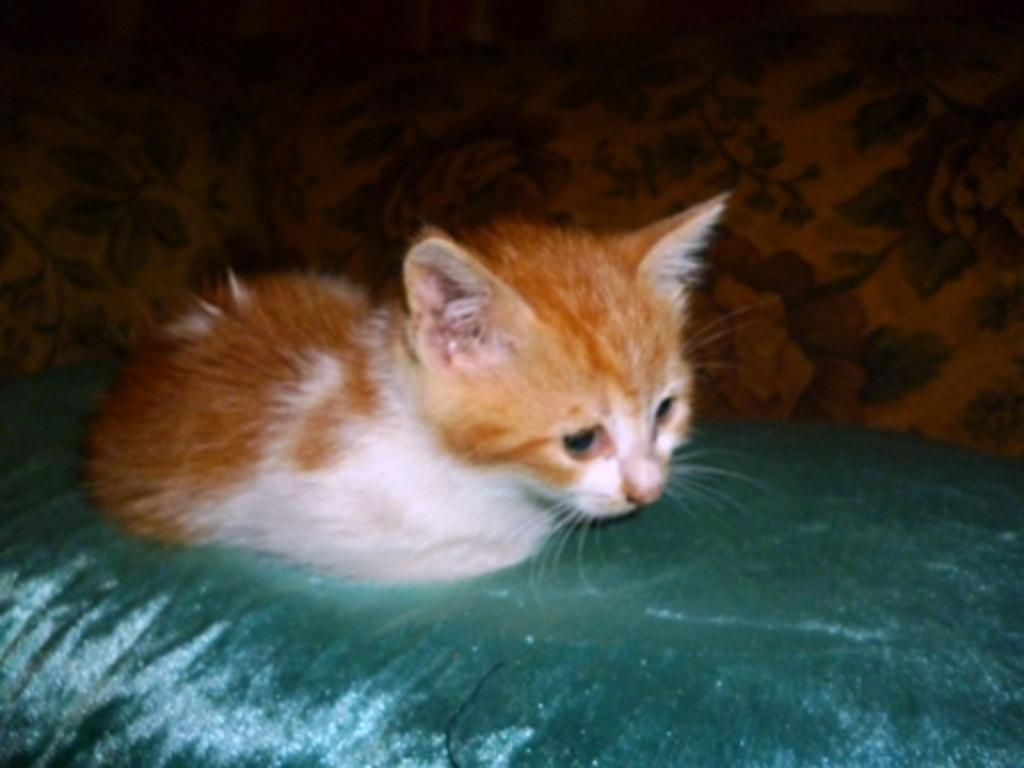What type of animal is in the image? There is a cat in the image. Can you describe the color of the cat? The cat has a brown and white color. What type of suit is the cat wearing in the image? There is no suit present in the image, as the cat is an animal and does not wear clothing. 